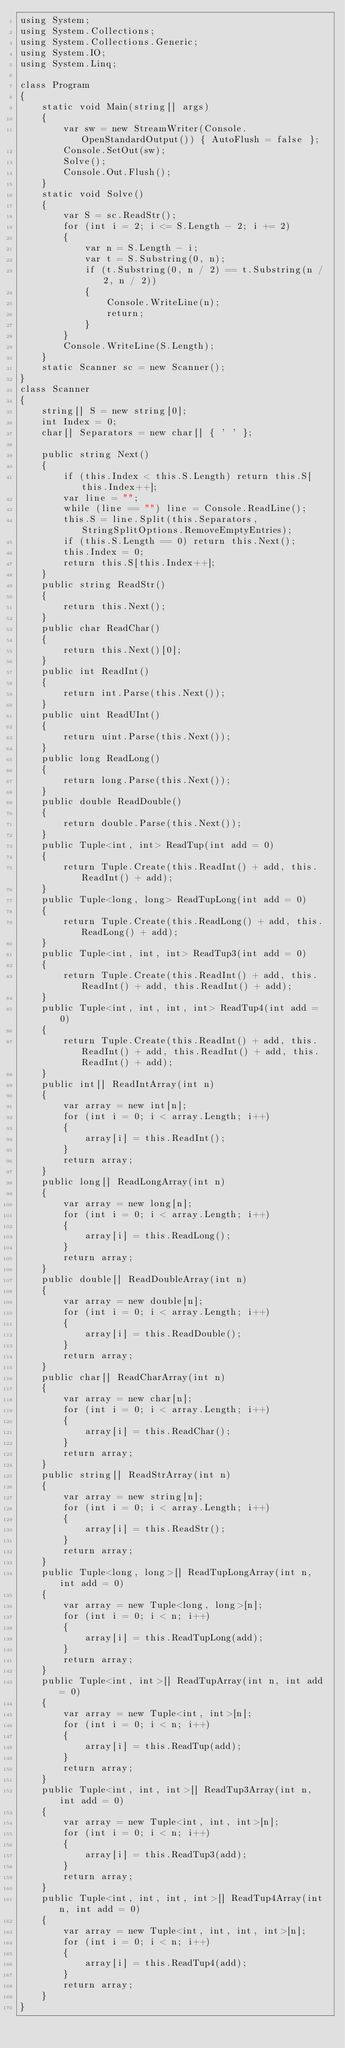<code> <loc_0><loc_0><loc_500><loc_500><_C#_>using System;
using System.Collections;
using System.Collections.Generic;
using System.IO;
using System.Linq;

class Program
{
    static void Main(string[] args)
    {
        var sw = new StreamWriter(Console.OpenStandardOutput()) { AutoFlush = false };
        Console.SetOut(sw);
        Solve();
        Console.Out.Flush();
    }
    static void Solve()
    {
        var S = sc.ReadStr();
        for (int i = 2; i <= S.Length - 2; i += 2)
        {
            var n = S.Length - i;
            var t = S.Substring(0, n);
            if (t.Substring(0, n / 2) == t.Substring(n / 2, n / 2))
            {
                Console.WriteLine(n);
                return;
            }
        }
        Console.WriteLine(S.Length);
    }
    static Scanner sc = new Scanner();
}
class Scanner
{
    string[] S = new string[0];
    int Index = 0;
    char[] Separators = new char[] { ' ' };

    public string Next()
    {
        if (this.Index < this.S.Length) return this.S[this.Index++];
        var line = "";
        while (line == "") line = Console.ReadLine();
        this.S = line.Split(this.Separators, StringSplitOptions.RemoveEmptyEntries);
        if (this.S.Length == 0) return this.Next();
        this.Index = 0;
        return this.S[this.Index++];
    }
    public string ReadStr()
    {
        return this.Next();
    }
    public char ReadChar()
    {
        return this.Next()[0];
    }
    public int ReadInt()
    {
        return int.Parse(this.Next());
    }
    public uint ReadUInt()
    {
        return uint.Parse(this.Next());
    }
    public long ReadLong()
    {
        return long.Parse(this.Next());
    }
    public double ReadDouble()
    {
        return double.Parse(this.Next());
    }
    public Tuple<int, int> ReadTup(int add = 0)
    {
        return Tuple.Create(this.ReadInt() + add, this.ReadInt() + add);
    }
    public Tuple<long, long> ReadTupLong(int add = 0)
    {
        return Tuple.Create(this.ReadLong() + add, this.ReadLong() + add);
    }
    public Tuple<int, int, int> ReadTup3(int add = 0)
    {
        return Tuple.Create(this.ReadInt() + add, this.ReadInt() + add, this.ReadInt() + add);
    }
    public Tuple<int, int, int, int> ReadTup4(int add = 0)
    {
        return Tuple.Create(this.ReadInt() + add, this.ReadInt() + add, this.ReadInt() + add, this.ReadInt() + add);
    }
    public int[] ReadIntArray(int n)
    {
        var array = new int[n];
        for (int i = 0; i < array.Length; i++)
        {
            array[i] = this.ReadInt();
        }
        return array;
    }
    public long[] ReadLongArray(int n)
    {
        var array = new long[n];
        for (int i = 0; i < array.Length; i++)
        {
            array[i] = this.ReadLong();
        }
        return array;
    }
    public double[] ReadDoubleArray(int n)
    {
        var array = new double[n];
        for (int i = 0; i < array.Length; i++)
        {
            array[i] = this.ReadDouble();
        }
        return array;
    }
    public char[] ReadCharArray(int n)
    {
        var array = new char[n];
        for (int i = 0; i < array.Length; i++)
        {
            array[i] = this.ReadChar();
        }
        return array;
    }
    public string[] ReadStrArray(int n)
    {
        var array = new string[n];
        for (int i = 0; i < array.Length; i++)
        {
            array[i] = this.ReadStr();
        }
        return array;
    }
    public Tuple<long, long>[] ReadTupLongArray(int n, int add = 0)
    {
        var array = new Tuple<long, long>[n];
        for (int i = 0; i < n; i++)
        {
            array[i] = this.ReadTupLong(add);
        }
        return array;
    }
    public Tuple<int, int>[] ReadTupArray(int n, int add = 0)
    {
        var array = new Tuple<int, int>[n];
        for (int i = 0; i < n; i++)
        {
            array[i] = this.ReadTup(add);
        }
        return array;
    }
    public Tuple<int, int, int>[] ReadTup3Array(int n, int add = 0)
    {
        var array = new Tuple<int, int, int>[n];
        for (int i = 0; i < n; i++)
        {
            array[i] = this.ReadTup3(add);
        }
        return array;
    }
    public Tuple<int, int, int, int>[] ReadTup4Array(int n, int add = 0)
    {
        var array = new Tuple<int, int, int, int>[n];
        for (int i = 0; i < n; i++)
        {
            array[i] = this.ReadTup4(add);
        }
        return array;
    }
}
</code> 